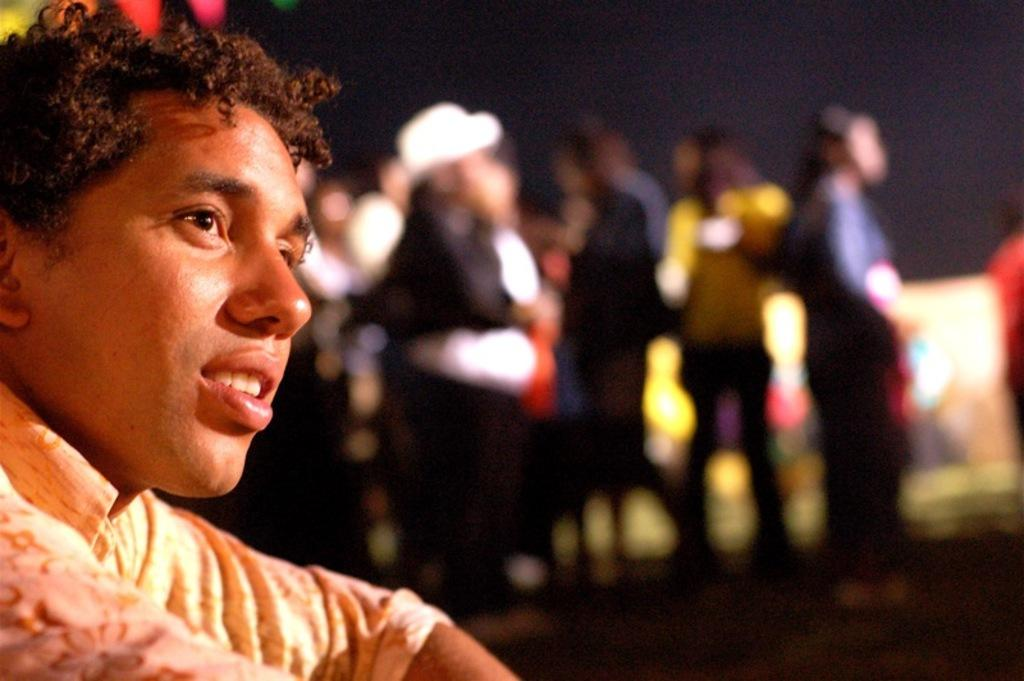How many people are in the image? There is a group of people in the image, but the exact number is not specified. What can be seen in the background of the image? The background of the image is dark. How many clocks are hanging on the wall in the image? There is no mention of clocks or a wall in the image, so it is not possible to answer that question. 